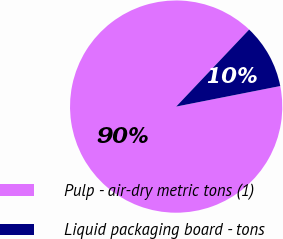Convert chart to OTSL. <chart><loc_0><loc_0><loc_500><loc_500><pie_chart><fcel>Pulp - air-dry metric tons (1)<fcel>Liquid packaging board - tons<nl><fcel>90.17%<fcel>9.83%<nl></chart> 